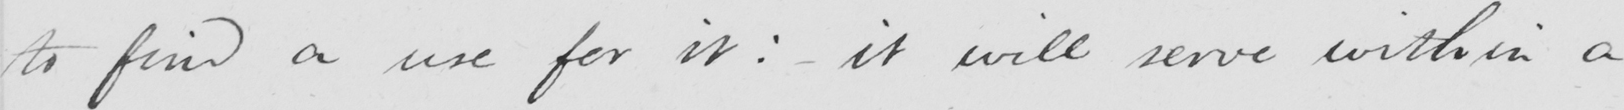Transcribe the text shown in this historical manuscript line. to find a use for it :   _  it will sever with in a 